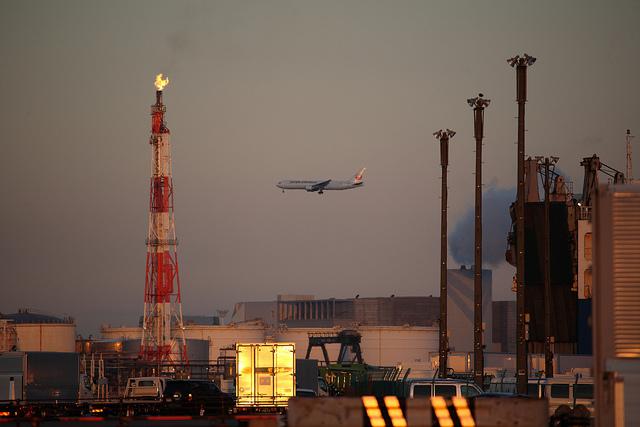What time of day is it?
Keep it brief. Evening. Is the plane ascending?
Be succinct. Yes. Is it getting dark?
Quick response, please. Yes. What mode of transportation is pictured?
Give a very brief answer. Airplane. 